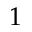Convert formula to latex. <formula><loc_0><loc_0><loc_500><loc_500>1</formula> 